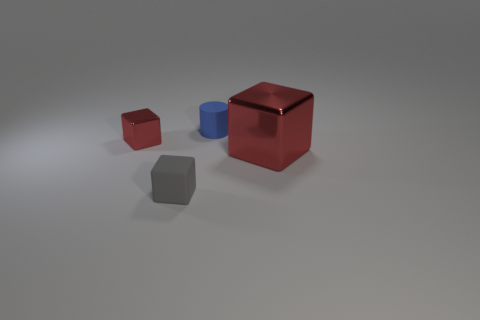Are there any objects right of the big red shiny block?
Provide a succinct answer. No. Is the number of red blocks to the right of the small blue thing less than the number of tiny blue blocks?
Offer a very short reply. No. What is the material of the small blue cylinder?
Offer a very short reply. Rubber. What is the color of the large thing?
Ensure brevity in your answer.  Red. The object that is both on the right side of the tiny red block and behind the large red thing is what color?
Your answer should be very brief. Blue. Is there anything else that is made of the same material as the big thing?
Provide a succinct answer. Yes. Is the material of the cylinder the same as the tiny cube in front of the large red object?
Make the answer very short. Yes. How big is the red block on the right side of the tiny shiny thing that is behind the gray matte thing?
Provide a short and direct response. Large. Is there anything else that has the same color as the small cylinder?
Your response must be concise. No. Are the red thing behind the big block and the small object in front of the large red cube made of the same material?
Ensure brevity in your answer.  No. 